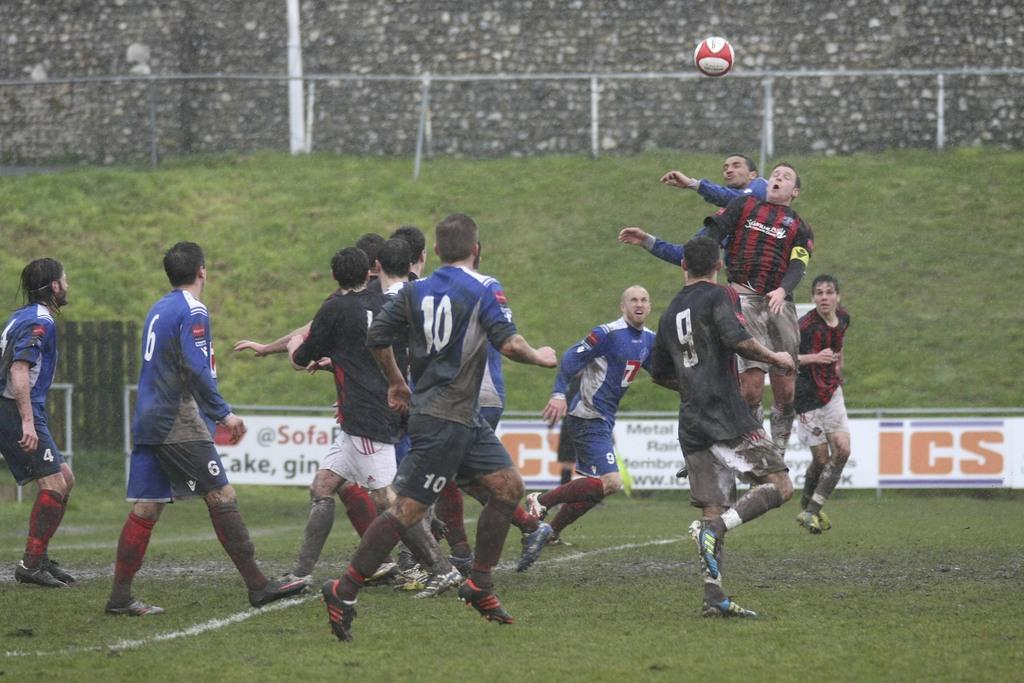<image>
Create a compact narrative representing the image presented. A banner that has the letters ICS on it. 